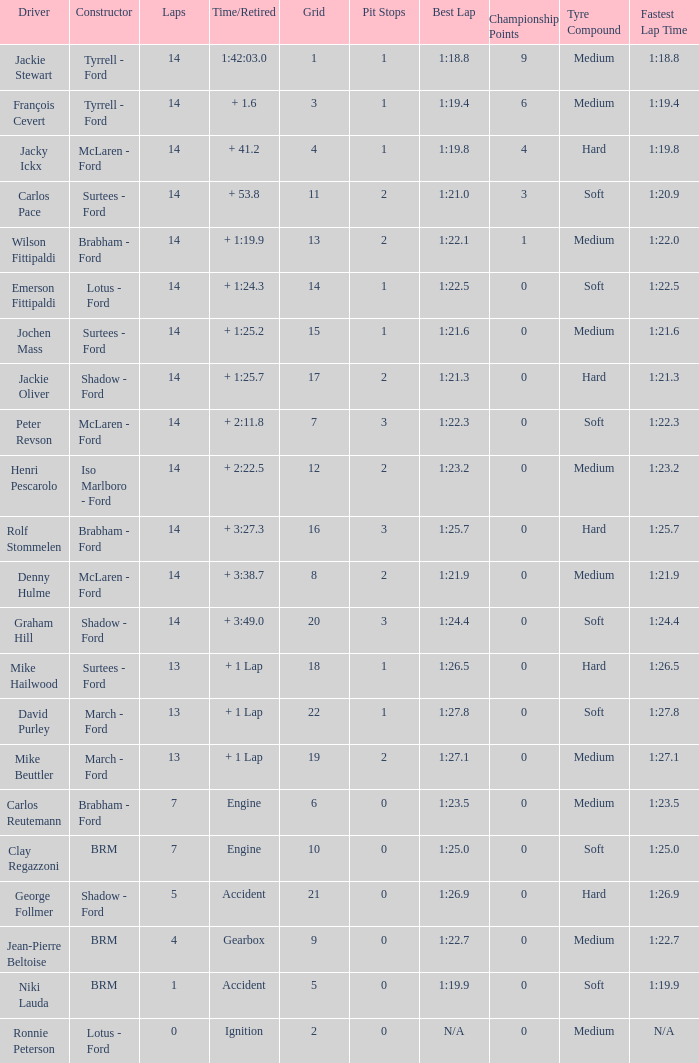What grad has a Time/Retired of + 1:24.3? 14.0. 